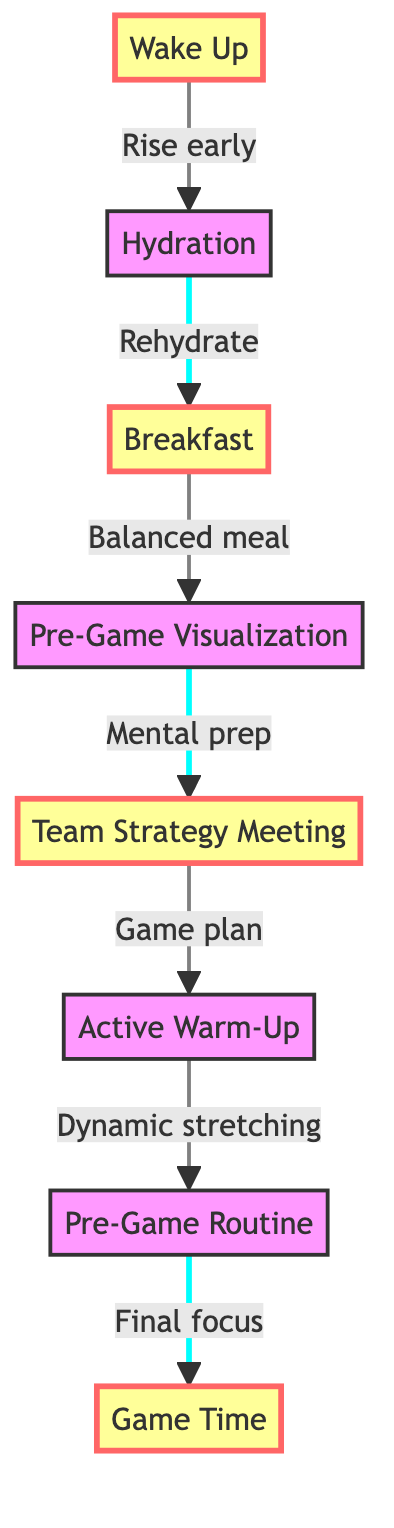What is the first step in the game day preparation process? The diagram starts with "Wake Up," indicating that this is the initial step in the preparation.
Answer: Wake Up How many steps are there in the game day preparation process? By counting the nodes in the flowchart, there are a total of eight distinct steps listed.
Answer: 8 What follows the hydration step? The flowchart shows an arrow leading from "Hydration" to "Breakfast," which means breakfast is the subsequent step.
Answer: Breakfast What is the last step before "Game Time"? According to the flowchart, the step preceding "Game Time" is "Pre-Game Routine," as shown by the directed arrows.
Answer: Pre-Game Routine Which step focuses on visualizing game scenarios? The step labeled "Pre-Game Visualization" specifically addresses the mental aspect of imagining different scenarios during the game.
Answer: Pre-Game Visualization What is the connection between "Team Strategy Meeting" and "Active Warm-Up"? The diagram indicates a direct flow from "Team Strategy Meeting" to "Active Warm-Up," which implies that these steps are sequentially linked.
Answer: Direct flow Which steps are marked as important in the diagram? The highlighted steps that are emphasized as important according to the diagram are "Wake Up," "Breakfast," "Team Strategy Meeting," and "Game Time."
Answer: Wake Up, Breakfast, Team Strategy Meeting, Game Time What is the purpose of the "Active Warm-Up" step? The description associated with "Active Warm-Up" specifies engagement in dynamic stretching and light drills as part of the preparation process.
Answer: Engage in dynamic stretching and light drills How does "Pre-Game Visualization" relate to "Team Strategy Meeting"? "Pre-Game Visualization" comes immediately after "Breakfast" and right before the "Team Strategy Meeting," indicating that visualization occurs before discussing strategies.
Answer: Visualization occurs before strategy discussion 